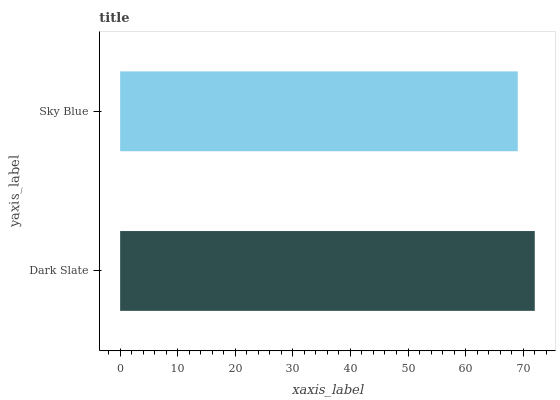Is Sky Blue the minimum?
Answer yes or no. Yes. Is Dark Slate the maximum?
Answer yes or no. Yes. Is Sky Blue the maximum?
Answer yes or no. No. Is Dark Slate greater than Sky Blue?
Answer yes or no. Yes. Is Sky Blue less than Dark Slate?
Answer yes or no. Yes. Is Sky Blue greater than Dark Slate?
Answer yes or no. No. Is Dark Slate less than Sky Blue?
Answer yes or no. No. Is Dark Slate the high median?
Answer yes or no. Yes. Is Sky Blue the low median?
Answer yes or no. Yes. Is Sky Blue the high median?
Answer yes or no. No. Is Dark Slate the low median?
Answer yes or no. No. 